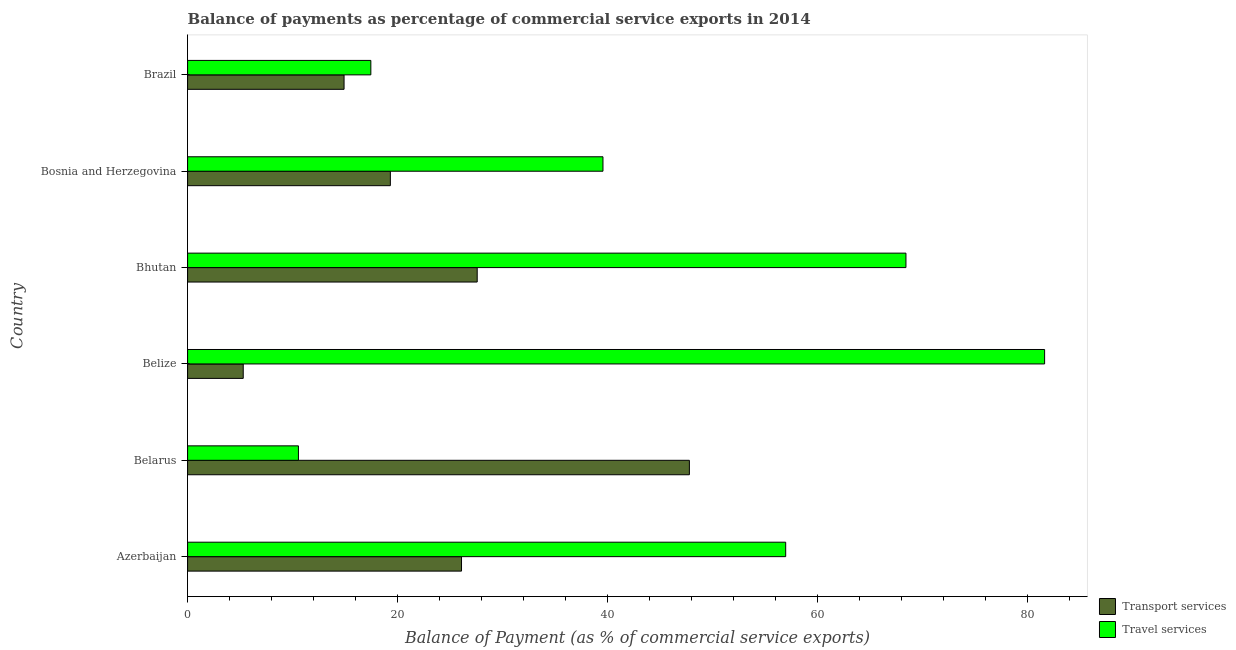How many different coloured bars are there?
Provide a short and direct response. 2. How many groups of bars are there?
Give a very brief answer. 6. Are the number of bars on each tick of the Y-axis equal?
Your answer should be very brief. Yes. What is the label of the 2nd group of bars from the top?
Offer a terse response. Bosnia and Herzegovina. What is the balance of payments of transport services in Brazil?
Provide a short and direct response. 14.9. Across all countries, what is the maximum balance of payments of transport services?
Your answer should be very brief. 47.79. Across all countries, what is the minimum balance of payments of transport services?
Your answer should be very brief. 5.3. In which country was the balance of payments of transport services maximum?
Make the answer very short. Belarus. In which country was the balance of payments of transport services minimum?
Give a very brief answer. Belize. What is the total balance of payments of transport services in the graph?
Offer a terse response. 140.97. What is the difference between the balance of payments of travel services in Belarus and that in Bosnia and Herzegovina?
Provide a succinct answer. -29. What is the difference between the balance of payments of transport services in Belarus and the balance of payments of travel services in Belize?
Give a very brief answer. -33.83. What is the average balance of payments of transport services per country?
Offer a very short reply. 23.49. What is the difference between the balance of payments of transport services and balance of payments of travel services in Belarus?
Ensure brevity in your answer.  37.23. In how many countries, is the balance of payments of travel services greater than 28 %?
Offer a very short reply. 4. What is the ratio of the balance of payments of transport services in Belarus to that in Brazil?
Provide a short and direct response. 3.21. Is the difference between the balance of payments of transport services in Belarus and Bosnia and Herzegovina greater than the difference between the balance of payments of travel services in Belarus and Bosnia and Herzegovina?
Offer a terse response. Yes. What is the difference between the highest and the second highest balance of payments of travel services?
Offer a terse response. 13.21. What is the difference between the highest and the lowest balance of payments of transport services?
Make the answer very short. 42.49. Is the sum of the balance of payments of travel services in Azerbaijan and Bosnia and Herzegovina greater than the maximum balance of payments of transport services across all countries?
Offer a terse response. Yes. What does the 2nd bar from the top in Azerbaijan represents?
Keep it short and to the point. Transport services. What does the 1st bar from the bottom in Brazil represents?
Make the answer very short. Transport services. How many bars are there?
Your answer should be very brief. 12. What is the difference between two consecutive major ticks on the X-axis?
Offer a very short reply. 20. How many legend labels are there?
Ensure brevity in your answer.  2. What is the title of the graph?
Keep it short and to the point. Balance of payments as percentage of commercial service exports in 2014. What is the label or title of the X-axis?
Your answer should be compact. Balance of Payment (as % of commercial service exports). What is the label or title of the Y-axis?
Offer a very short reply. Country. What is the Balance of Payment (as % of commercial service exports) in Transport services in Azerbaijan?
Offer a terse response. 26.09. What is the Balance of Payment (as % of commercial service exports) of Travel services in Azerbaijan?
Your answer should be very brief. 56.96. What is the Balance of Payment (as % of commercial service exports) in Transport services in Belarus?
Keep it short and to the point. 47.79. What is the Balance of Payment (as % of commercial service exports) in Travel services in Belarus?
Provide a succinct answer. 10.56. What is the Balance of Payment (as % of commercial service exports) in Transport services in Belize?
Give a very brief answer. 5.3. What is the Balance of Payment (as % of commercial service exports) in Travel services in Belize?
Keep it short and to the point. 81.62. What is the Balance of Payment (as % of commercial service exports) in Transport services in Bhutan?
Make the answer very short. 27.58. What is the Balance of Payment (as % of commercial service exports) in Travel services in Bhutan?
Your answer should be compact. 68.41. What is the Balance of Payment (as % of commercial service exports) of Transport services in Bosnia and Herzegovina?
Your response must be concise. 19.31. What is the Balance of Payment (as % of commercial service exports) of Travel services in Bosnia and Herzegovina?
Offer a terse response. 39.56. What is the Balance of Payment (as % of commercial service exports) of Transport services in Brazil?
Your response must be concise. 14.9. What is the Balance of Payment (as % of commercial service exports) in Travel services in Brazil?
Give a very brief answer. 17.45. Across all countries, what is the maximum Balance of Payment (as % of commercial service exports) in Transport services?
Your response must be concise. 47.79. Across all countries, what is the maximum Balance of Payment (as % of commercial service exports) in Travel services?
Give a very brief answer. 81.62. Across all countries, what is the minimum Balance of Payment (as % of commercial service exports) in Transport services?
Make the answer very short. 5.3. Across all countries, what is the minimum Balance of Payment (as % of commercial service exports) in Travel services?
Keep it short and to the point. 10.56. What is the total Balance of Payment (as % of commercial service exports) in Transport services in the graph?
Give a very brief answer. 140.97. What is the total Balance of Payment (as % of commercial service exports) of Travel services in the graph?
Offer a terse response. 274.55. What is the difference between the Balance of Payment (as % of commercial service exports) of Transport services in Azerbaijan and that in Belarus?
Provide a short and direct response. -21.7. What is the difference between the Balance of Payment (as % of commercial service exports) of Travel services in Azerbaijan and that in Belarus?
Give a very brief answer. 46.4. What is the difference between the Balance of Payment (as % of commercial service exports) in Transport services in Azerbaijan and that in Belize?
Your answer should be compact. 20.79. What is the difference between the Balance of Payment (as % of commercial service exports) in Travel services in Azerbaijan and that in Belize?
Your answer should be compact. -24.66. What is the difference between the Balance of Payment (as % of commercial service exports) in Transport services in Azerbaijan and that in Bhutan?
Offer a terse response. -1.49. What is the difference between the Balance of Payment (as % of commercial service exports) of Travel services in Azerbaijan and that in Bhutan?
Your answer should be compact. -11.45. What is the difference between the Balance of Payment (as % of commercial service exports) in Transport services in Azerbaijan and that in Bosnia and Herzegovina?
Offer a terse response. 6.78. What is the difference between the Balance of Payment (as % of commercial service exports) in Travel services in Azerbaijan and that in Bosnia and Herzegovina?
Provide a short and direct response. 17.4. What is the difference between the Balance of Payment (as % of commercial service exports) in Transport services in Azerbaijan and that in Brazil?
Make the answer very short. 11.19. What is the difference between the Balance of Payment (as % of commercial service exports) of Travel services in Azerbaijan and that in Brazil?
Your response must be concise. 39.51. What is the difference between the Balance of Payment (as % of commercial service exports) of Transport services in Belarus and that in Belize?
Offer a terse response. 42.49. What is the difference between the Balance of Payment (as % of commercial service exports) of Travel services in Belarus and that in Belize?
Your answer should be compact. -71.06. What is the difference between the Balance of Payment (as % of commercial service exports) in Transport services in Belarus and that in Bhutan?
Your answer should be very brief. 20.21. What is the difference between the Balance of Payment (as % of commercial service exports) in Travel services in Belarus and that in Bhutan?
Your response must be concise. -57.86. What is the difference between the Balance of Payment (as % of commercial service exports) in Transport services in Belarus and that in Bosnia and Herzegovina?
Provide a short and direct response. 28.48. What is the difference between the Balance of Payment (as % of commercial service exports) of Travel services in Belarus and that in Bosnia and Herzegovina?
Ensure brevity in your answer.  -29. What is the difference between the Balance of Payment (as % of commercial service exports) in Transport services in Belarus and that in Brazil?
Provide a short and direct response. 32.89. What is the difference between the Balance of Payment (as % of commercial service exports) of Travel services in Belarus and that in Brazil?
Provide a succinct answer. -6.9. What is the difference between the Balance of Payment (as % of commercial service exports) of Transport services in Belize and that in Bhutan?
Ensure brevity in your answer.  -22.28. What is the difference between the Balance of Payment (as % of commercial service exports) in Travel services in Belize and that in Bhutan?
Give a very brief answer. 13.21. What is the difference between the Balance of Payment (as % of commercial service exports) in Transport services in Belize and that in Bosnia and Herzegovina?
Provide a short and direct response. -14.01. What is the difference between the Balance of Payment (as % of commercial service exports) in Travel services in Belize and that in Bosnia and Herzegovina?
Your answer should be very brief. 42.06. What is the difference between the Balance of Payment (as % of commercial service exports) of Transport services in Belize and that in Brazil?
Keep it short and to the point. -9.6. What is the difference between the Balance of Payment (as % of commercial service exports) of Travel services in Belize and that in Brazil?
Offer a terse response. 64.17. What is the difference between the Balance of Payment (as % of commercial service exports) in Transport services in Bhutan and that in Bosnia and Herzegovina?
Keep it short and to the point. 8.27. What is the difference between the Balance of Payment (as % of commercial service exports) of Travel services in Bhutan and that in Bosnia and Herzegovina?
Provide a succinct answer. 28.85. What is the difference between the Balance of Payment (as % of commercial service exports) of Transport services in Bhutan and that in Brazil?
Provide a short and direct response. 12.68. What is the difference between the Balance of Payment (as % of commercial service exports) in Travel services in Bhutan and that in Brazil?
Your answer should be compact. 50.96. What is the difference between the Balance of Payment (as % of commercial service exports) of Transport services in Bosnia and Herzegovina and that in Brazil?
Offer a terse response. 4.41. What is the difference between the Balance of Payment (as % of commercial service exports) in Travel services in Bosnia and Herzegovina and that in Brazil?
Your answer should be compact. 22.11. What is the difference between the Balance of Payment (as % of commercial service exports) of Transport services in Azerbaijan and the Balance of Payment (as % of commercial service exports) of Travel services in Belarus?
Ensure brevity in your answer.  15.53. What is the difference between the Balance of Payment (as % of commercial service exports) of Transport services in Azerbaijan and the Balance of Payment (as % of commercial service exports) of Travel services in Belize?
Provide a short and direct response. -55.53. What is the difference between the Balance of Payment (as % of commercial service exports) of Transport services in Azerbaijan and the Balance of Payment (as % of commercial service exports) of Travel services in Bhutan?
Provide a succinct answer. -42.33. What is the difference between the Balance of Payment (as % of commercial service exports) of Transport services in Azerbaijan and the Balance of Payment (as % of commercial service exports) of Travel services in Bosnia and Herzegovina?
Provide a short and direct response. -13.47. What is the difference between the Balance of Payment (as % of commercial service exports) of Transport services in Azerbaijan and the Balance of Payment (as % of commercial service exports) of Travel services in Brazil?
Your answer should be compact. 8.64. What is the difference between the Balance of Payment (as % of commercial service exports) in Transport services in Belarus and the Balance of Payment (as % of commercial service exports) in Travel services in Belize?
Provide a succinct answer. -33.83. What is the difference between the Balance of Payment (as % of commercial service exports) of Transport services in Belarus and the Balance of Payment (as % of commercial service exports) of Travel services in Bhutan?
Your response must be concise. -20.62. What is the difference between the Balance of Payment (as % of commercial service exports) in Transport services in Belarus and the Balance of Payment (as % of commercial service exports) in Travel services in Bosnia and Herzegovina?
Keep it short and to the point. 8.23. What is the difference between the Balance of Payment (as % of commercial service exports) in Transport services in Belarus and the Balance of Payment (as % of commercial service exports) in Travel services in Brazil?
Ensure brevity in your answer.  30.34. What is the difference between the Balance of Payment (as % of commercial service exports) in Transport services in Belize and the Balance of Payment (as % of commercial service exports) in Travel services in Bhutan?
Keep it short and to the point. -63.11. What is the difference between the Balance of Payment (as % of commercial service exports) of Transport services in Belize and the Balance of Payment (as % of commercial service exports) of Travel services in Bosnia and Herzegovina?
Your answer should be compact. -34.26. What is the difference between the Balance of Payment (as % of commercial service exports) of Transport services in Belize and the Balance of Payment (as % of commercial service exports) of Travel services in Brazil?
Offer a very short reply. -12.15. What is the difference between the Balance of Payment (as % of commercial service exports) in Transport services in Bhutan and the Balance of Payment (as % of commercial service exports) in Travel services in Bosnia and Herzegovina?
Your answer should be compact. -11.98. What is the difference between the Balance of Payment (as % of commercial service exports) in Transport services in Bhutan and the Balance of Payment (as % of commercial service exports) in Travel services in Brazil?
Offer a very short reply. 10.13. What is the difference between the Balance of Payment (as % of commercial service exports) of Transport services in Bosnia and Herzegovina and the Balance of Payment (as % of commercial service exports) of Travel services in Brazil?
Give a very brief answer. 1.86. What is the average Balance of Payment (as % of commercial service exports) in Transport services per country?
Your answer should be compact. 23.49. What is the average Balance of Payment (as % of commercial service exports) in Travel services per country?
Provide a short and direct response. 45.76. What is the difference between the Balance of Payment (as % of commercial service exports) of Transport services and Balance of Payment (as % of commercial service exports) of Travel services in Azerbaijan?
Provide a short and direct response. -30.87. What is the difference between the Balance of Payment (as % of commercial service exports) of Transport services and Balance of Payment (as % of commercial service exports) of Travel services in Belarus?
Offer a terse response. 37.23. What is the difference between the Balance of Payment (as % of commercial service exports) of Transport services and Balance of Payment (as % of commercial service exports) of Travel services in Belize?
Provide a succinct answer. -76.32. What is the difference between the Balance of Payment (as % of commercial service exports) of Transport services and Balance of Payment (as % of commercial service exports) of Travel services in Bhutan?
Provide a succinct answer. -40.83. What is the difference between the Balance of Payment (as % of commercial service exports) of Transport services and Balance of Payment (as % of commercial service exports) of Travel services in Bosnia and Herzegovina?
Keep it short and to the point. -20.25. What is the difference between the Balance of Payment (as % of commercial service exports) in Transport services and Balance of Payment (as % of commercial service exports) in Travel services in Brazil?
Offer a terse response. -2.55. What is the ratio of the Balance of Payment (as % of commercial service exports) in Transport services in Azerbaijan to that in Belarus?
Provide a succinct answer. 0.55. What is the ratio of the Balance of Payment (as % of commercial service exports) in Travel services in Azerbaijan to that in Belarus?
Your answer should be compact. 5.4. What is the ratio of the Balance of Payment (as % of commercial service exports) in Transport services in Azerbaijan to that in Belize?
Offer a very short reply. 4.92. What is the ratio of the Balance of Payment (as % of commercial service exports) of Travel services in Azerbaijan to that in Belize?
Provide a short and direct response. 0.7. What is the ratio of the Balance of Payment (as % of commercial service exports) in Transport services in Azerbaijan to that in Bhutan?
Your answer should be compact. 0.95. What is the ratio of the Balance of Payment (as % of commercial service exports) of Travel services in Azerbaijan to that in Bhutan?
Make the answer very short. 0.83. What is the ratio of the Balance of Payment (as % of commercial service exports) of Transport services in Azerbaijan to that in Bosnia and Herzegovina?
Provide a succinct answer. 1.35. What is the ratio of the Balance of Payment (as % of commercial service exports) in Travel services in Azerbaijan to that in Bosnia and Herzegovina?
Your answer should be compact. 1.44. What is the ratio of the Balance of Payment (as % of commercial service exports) in Transport services in Azerbaijan to that in Brazil?
Offer a terse response. 1.75. What is the ratio of the Balance of Payment (as % of commercial service exports) in Travel services in Azerbaijan to that in Brazil?
Offer a terse response. 3.26. What is the ratio of the Balance of Payment (as % of commercial service exports) in Transport services in Belarus to that in Belize?
Keep it short and to the point. 9.02. What is the ratio of the Balance of Payment (as % of commercial service exports) of Travel services in Belarus to that in Belize?
Provide a short and direct response. 0.13. What is the ratio of the Balance of Payment (as % of commercial service exports) of Transport services in Belarus to that in Bhutan?
Provide a succinct answer. 1.73. What is the ratio of the Balance of Payment (as % of commercial service exports) of Travel services in Belarus to that in Bhutan?
Offer a very short reply. 0.15. What is the ratio of the Balance of Payment (as % of commercial service exports) in Transport services in Belarus to that in Bosnia and Herzegovina?
Ensure brevity in your answer.  2.47. What is the ratio of the Balance of Payment (as % of commercial service exports) of Travel services in Belarus to that in Bosnia and Herzegovina?
Offer a very short reply. 0.27. What is the ratio of the Balance of Payment (as % of commercial service exports) of Transport services in Belarus to that in Brazil?
Provide a succinct answer. 3.21. What is the ratio of the Balance of Payment (as % of commercial service exports) of Travel services in Belarus to that in Brazil?
Offer a terse response. 0.6. What is the ratio of the Balance of Payment (as % of commercial service exports) of Transport services in Belize to that in Bhutan?
Provide a succinct answer. 0.19. What is the ratio of the Balance of Payment (as % of commercial service exports) in Travel services in Belize to that in Bhutan?
Ensure brevity in your answer.  1.19. What is the ratio of the Balance of Payment (as % of commercial service exports) in Transport services in Belize to that in Bosnia and Herzegovina?
Ensure brevity in your answer.  0.27. What is the ratio of the Balance of Payment (as % of commercial service exports) of Travel services in Belize to that in Bosnia and Herzegovina?
Your answer should be very brief. 2.06. What is the ratio of the Balance of Payment (as % of commercial service exports) of Transport services in Belize to that in Brazil?
Offer a very short reply. 0.36. What is the ratio of the Balance of Payment (as % of commercial service exports) of Travel services in Belize to that in Brazil?
Offer a terse response. 4.68. What is the ratio of the Balance of Payment (as % of commercial service exports) of Transport services in Bhutan to that in Bosnia and Herzegovina?
Keep it short and to the point. 1.43. What is the ratio of the Balance of Payment (as % of commercial service exports) of Travel services in Bhutan to that in Bosnia and Herzegovina?
Provide a succinct answer. 1.73. What is the ratio of the Balance of Payment (as % of commercial service exports) of Transport services in Bhutan to that in Brazil?
Your response must be concise. 1.85. What is the ratio of the Balance of Payment (as % of commercial service exports) of Travel services in Bhutan to that in Brazil?
Ensure brevity in your answer.  3.92. What is the ratio of the Balance of Payment (as % of commercial service exports) in Transport services in Bosnia and Herzegovina to that in Brazil?
Your response must be concise. 1.3. What is the ratio of the Balance of Payment (as % of commercial service exports) in Travel services in Bosnia and Herzegovina to that in Brazil?
Make the answer very short. 2.27. What is the difference between the highest and the second highest Balance of Payment (as % of commercial service exports) of Transport services?
Your answer should be compact. 20.21. What is the difference between the highest and the second highest Balance of Payment (as % of commercial service exports) of Travel services?
Keep it short and to the point. 13.21. What is the difference between the highest and the lowest Balance of Payment (as % of commercial service exports) in Transport services?
Your answer should be compact. 42.49. What is the difference between the highest and the lowest Balance of Payment (as % of commercial service exports) of Travel services?
Provide a short and direct response. 71.06. 